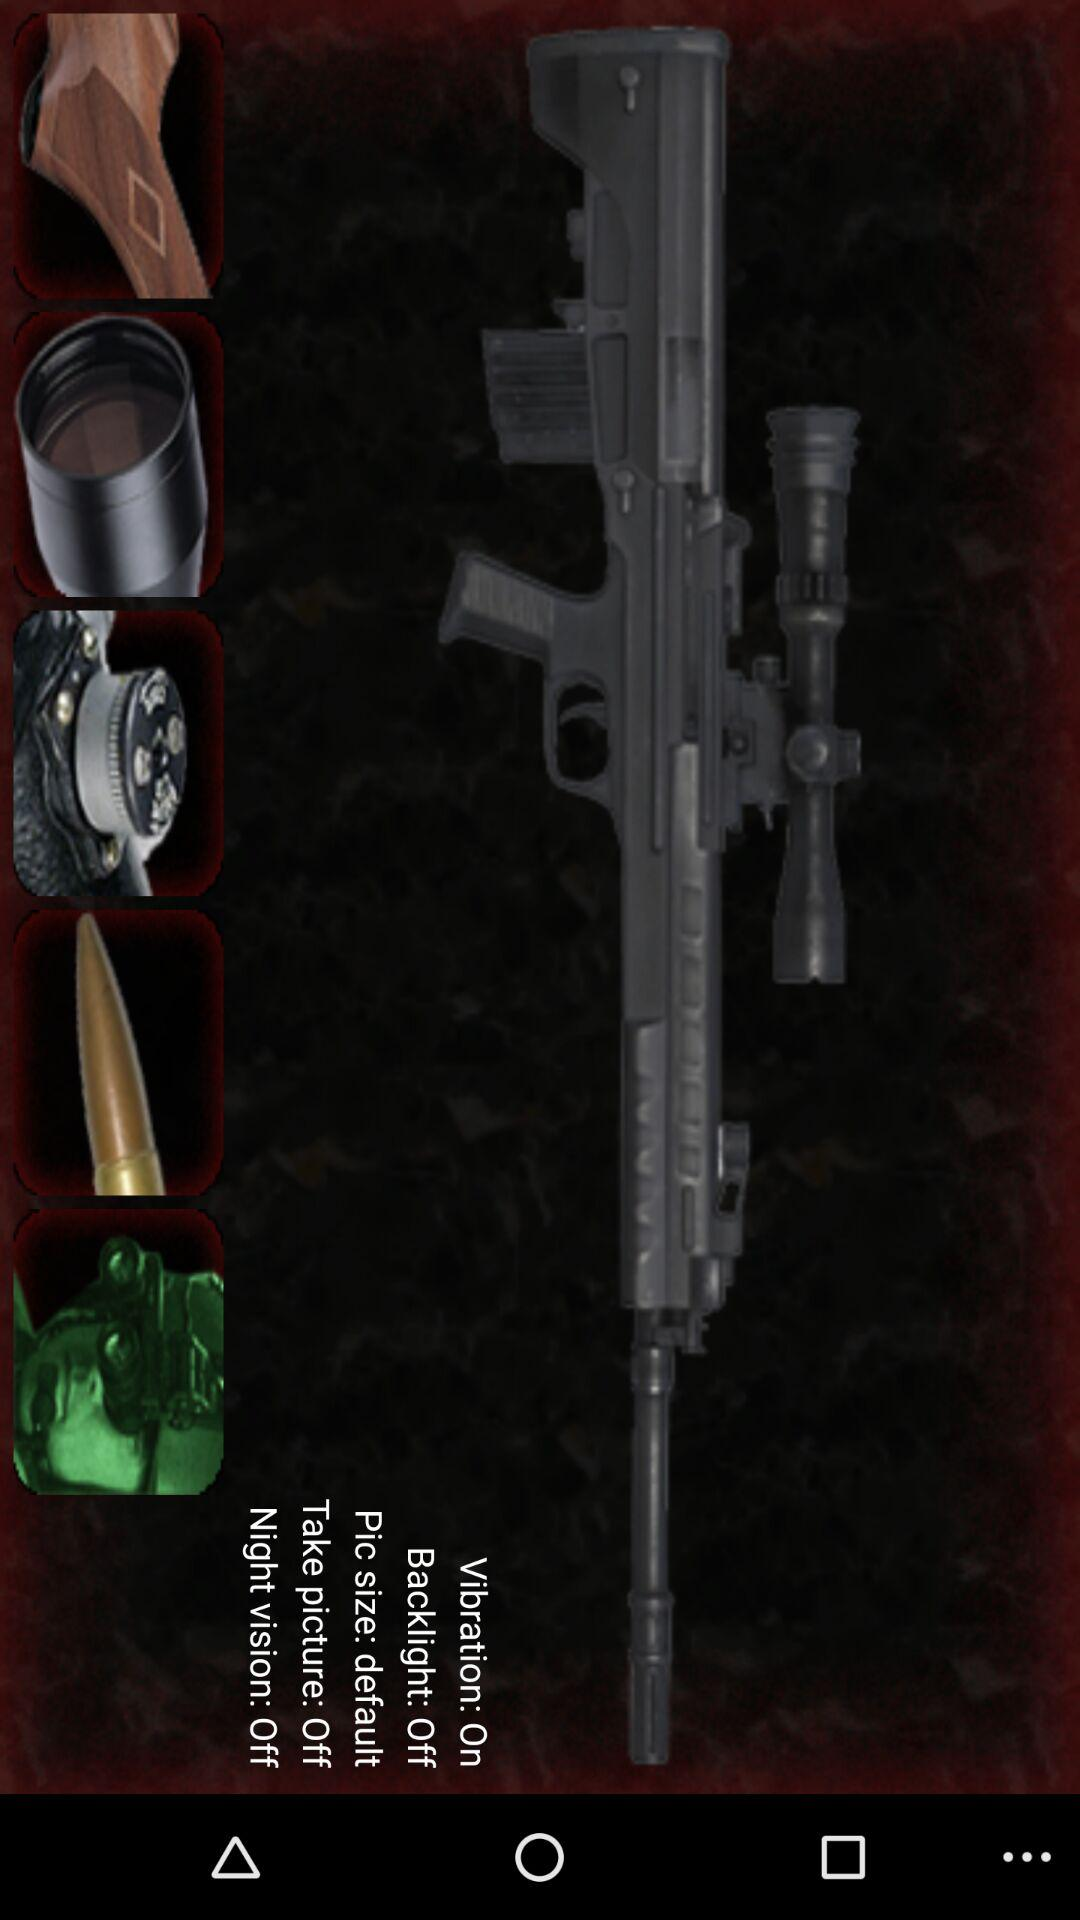What is the status of "Vibration"? The status is "on". 